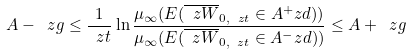Convert formula to latex. <formula><loc_0><loc_0><loc_500><loc_500>A - \ z g \leq \frac { 1 } { \ z t } \ln \frac { \mu _ { \infty } ( E ( \overline { \ z W } _ { 0 , \ z t } \in A ^ { + } _ { \ } z d ) ) } { \mu _ { \infty } ( E ( \overline { \ z W } _ { 0 , \ z t } \in A ^ { - } _ { \ } z d ) ) } \leq A + \ z g</formula> 